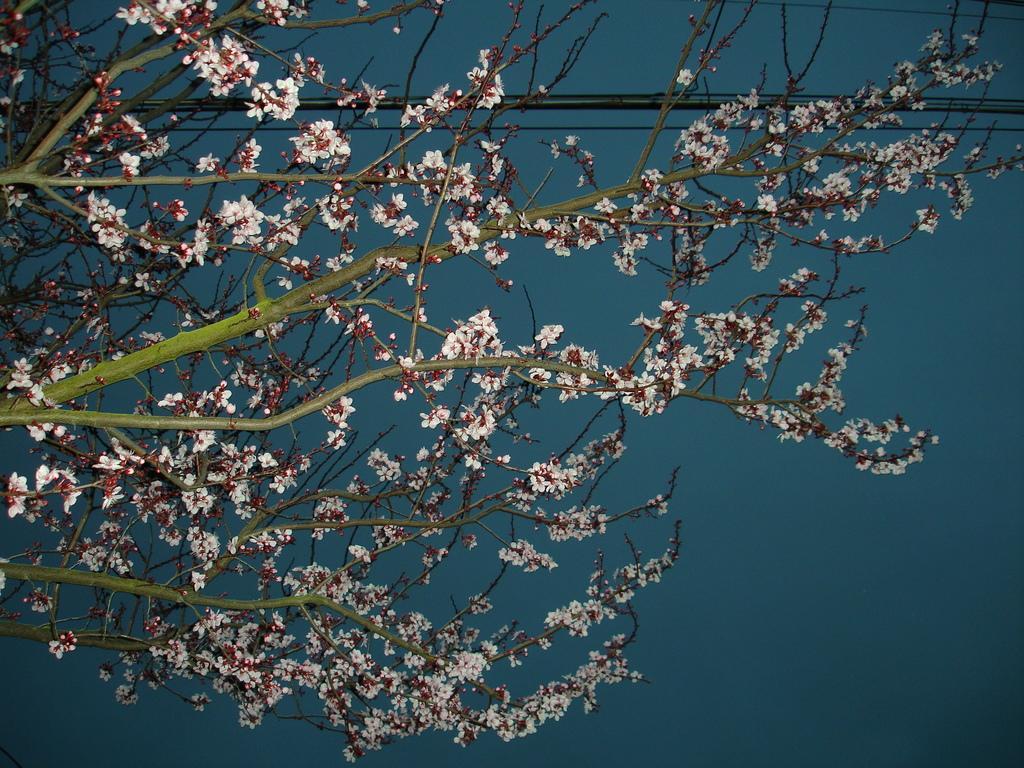Can you describe this image briefly? In this image, we can see a branch and wire on the blue background. 